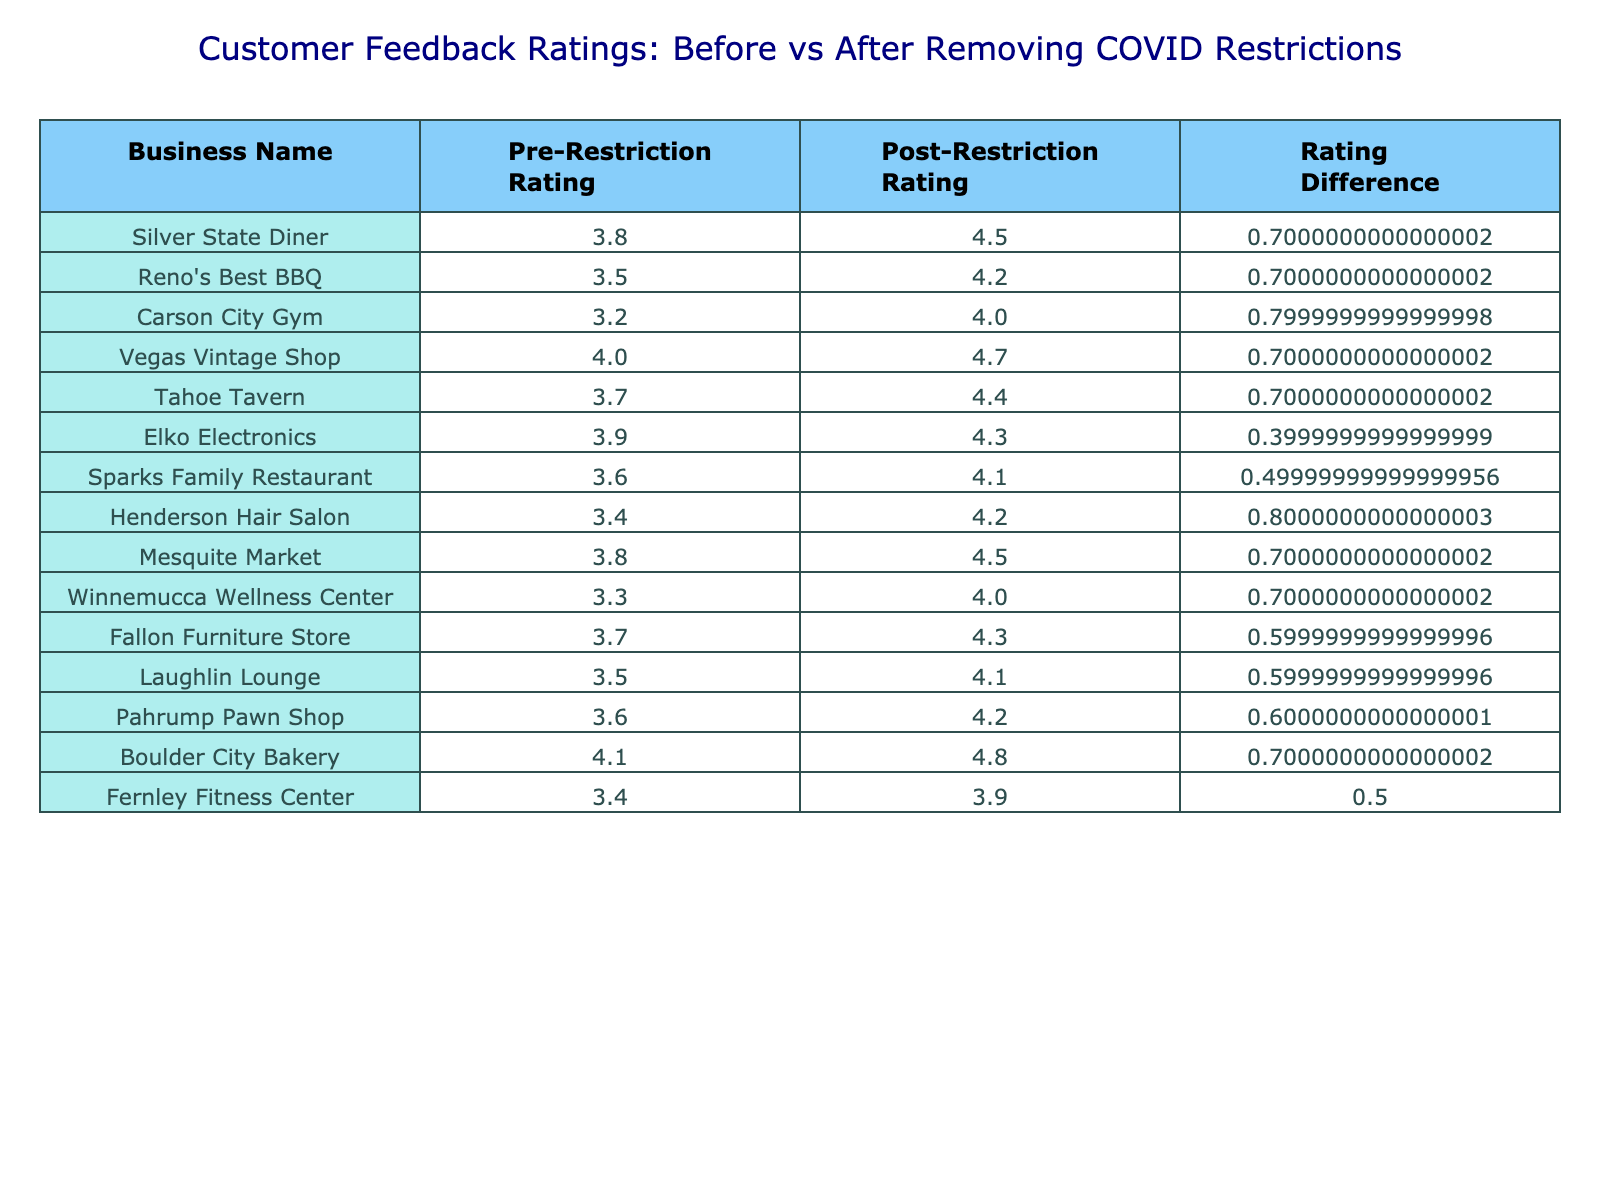What is the post-restriction rating of Silver State Diner? The post-restriction rating of Silver State Diner can be found in the corresponding column labeled "Post-Restriction Rating." Looking at the table, it shows that the rating is 4.5.
Answer: 4.5 Which business had the highest post-restriction rating? By examining the "Post-Restriction Rating" column, we can identify the highest value. The highest rating is 4.8, which belongs to Boulder City Bakery.
Answer: Boulder City Bakery What is the average pre-restriction rating across all businesses? To calculate the average pre-restriction rating, first, sum all the pre-restriction ratings: 3.8 + 3.5 + 3.2 + 4.0 + 3.7 + 3.9 + 3.6 + 3.4 + 3.8 + 3.3 + 3.7 + 3.5 + 3.6 + 4.1 + 3.4 = 53.0. There are 15 businesses, so divide the total by 15. The average is 53.0 / 15 = 3.53.
Answer: 3.53 Did any business see a post-restriction rating that was lower than their pre-restriction rating? To answer this, we check the "Post-Restriction Rating" for each business and compare it to the corresponding "Pre-Restriction Rating." All businesses have a higher post-restriction rating than their pre-restriction rating, so the answer is no.
Answer: No What is the total increase in ratings from pre-restraint to post-restriction for Reno's Best BBQ and Sparks Family Restaurant combined? First, find the post-restriction ratings: Reno's Best BBQ increased from 3.5 to 4.2, a difference of 0.7. Sparks Family Restaurant increased from 3.6 to 4.1, a difference of 0.5. Add these differences together: 0.7 + 0.5 = 1.2.
Answer: 1.2 